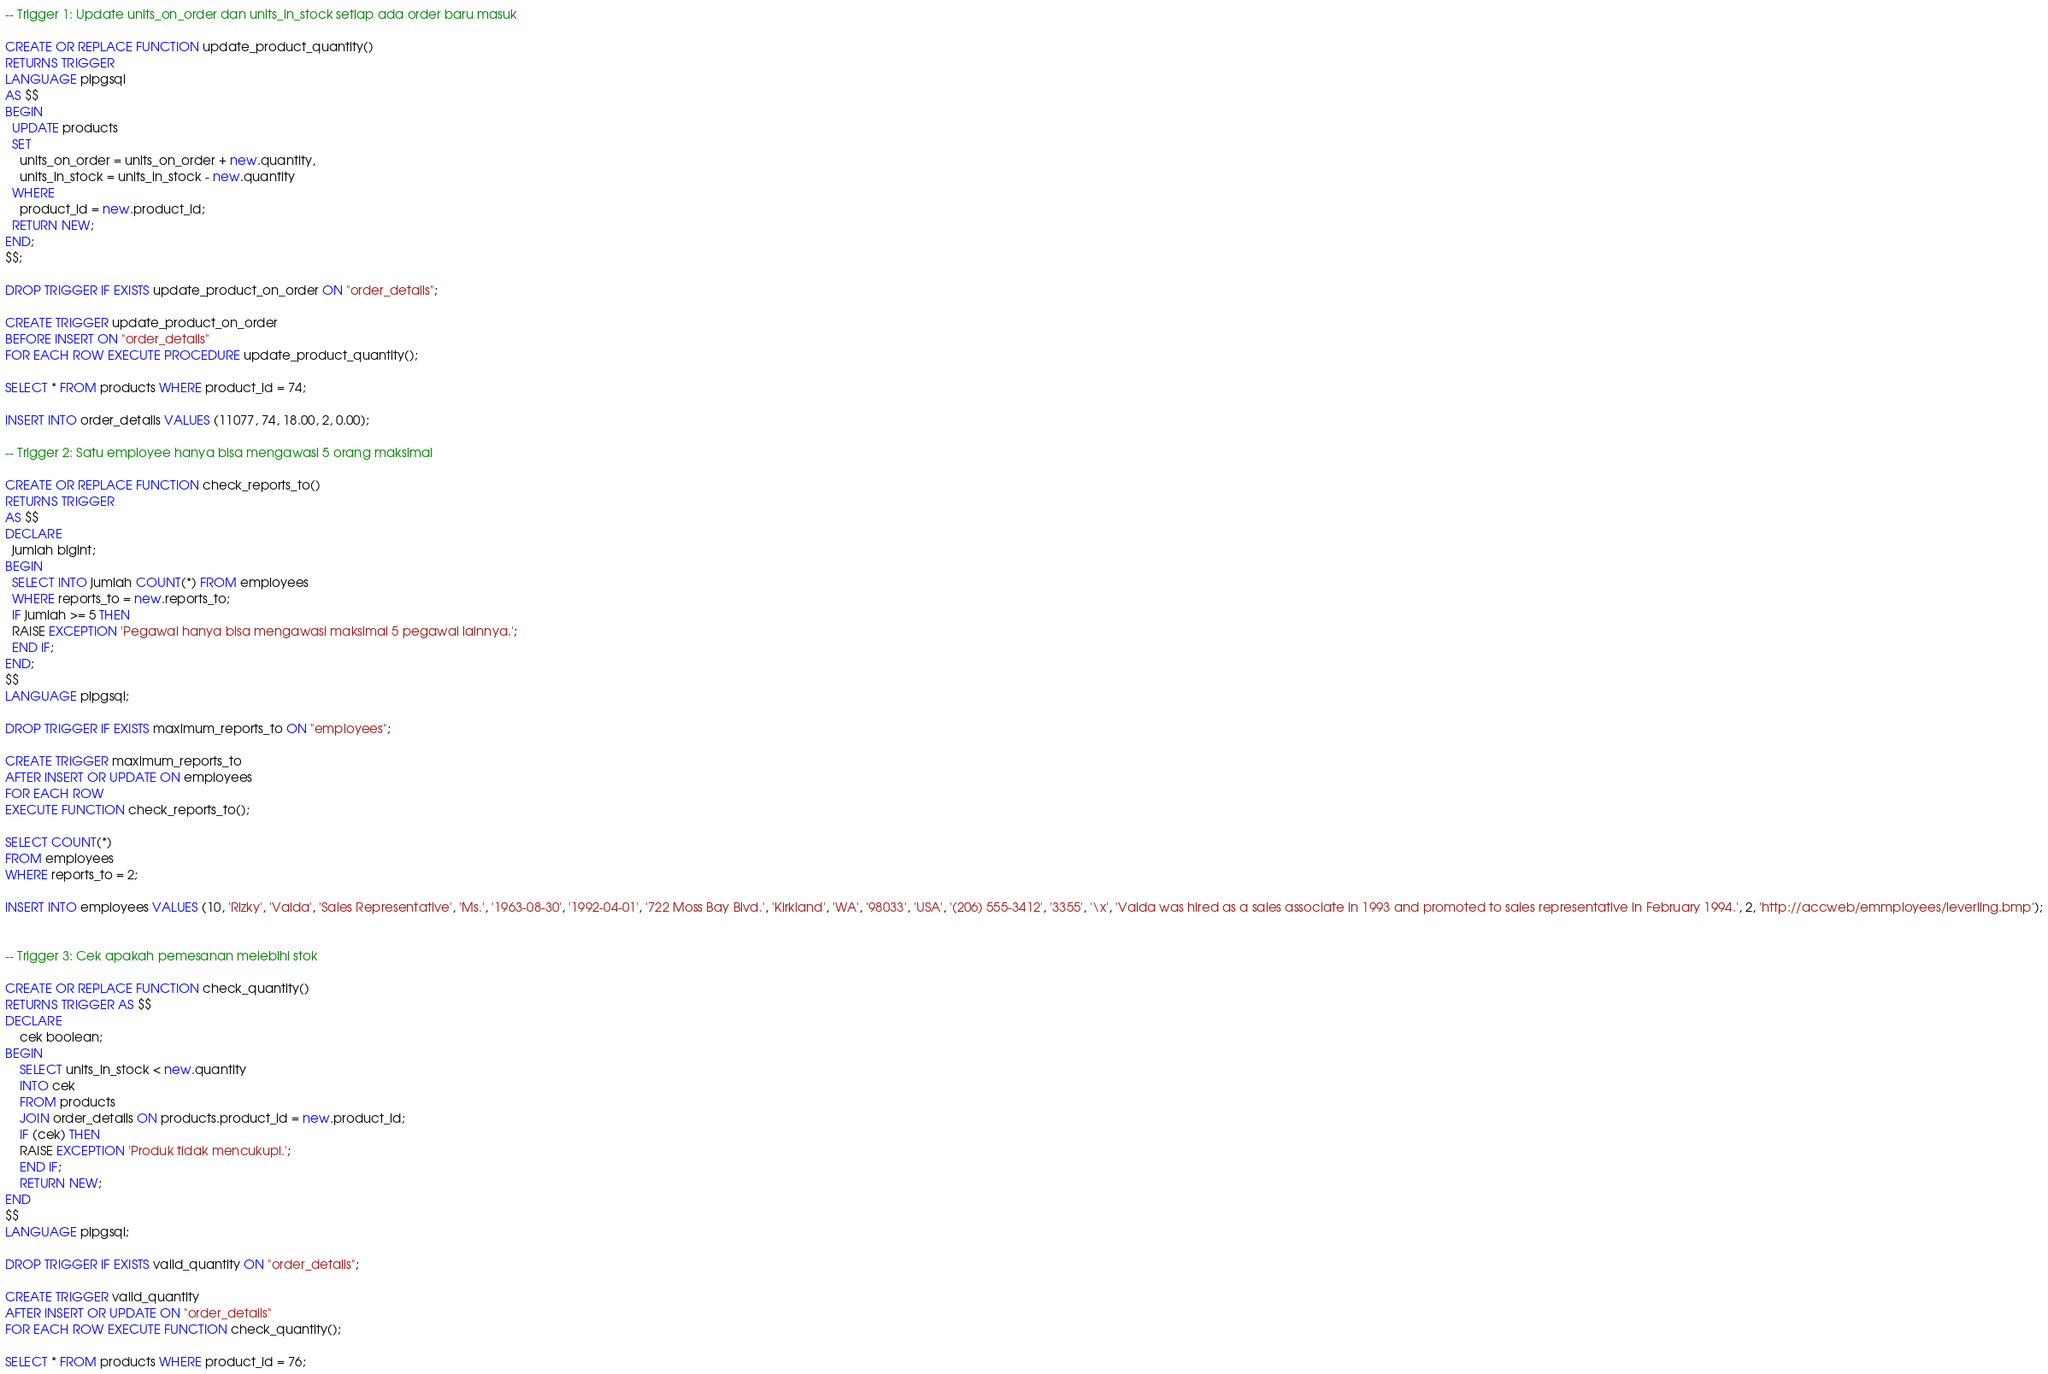<code> <loc_0><loc_0><loc_500><loc_500><_SQL_>-- Trigger 1: Update units_on_order dan units_in_stock setiap ada order baru masuk

CREATE OR REPLACE FUNCTION update_product_quantity()
RETURNS TRIGGER
LANGUAGE plpgsql
AS $$
BEGIN
  UPDATE products
  SET
    units_on_order = units_on_order + new.quantity,
    units_in_stock = units_in_stock - new.quantity
  WHERE
    product_id = new.product_id;
  RETURN NEW;
END;
$$;

DROP TRIGGER IF EXISTS update_product_on_order ON "order_details";

CREATE TRIGGER update_product_on_order 
BEFORE INSERT ON "order_details"
FOR EACH ROW EXECUTE PROCEDURE update_product_quantity();

SELECT * FROM products WHERE product_id = 74;

INSERT INTO order_details VALUES (11077, 74, 18.00, 2, 0.00);

-- Trigger 2: Satu employee hanya bisa mengawasi 5 orang maksimal

CREATE OR REPLACE FUNCTION check_reports_to()
RETURNS TRIGGER
AS $$
DECLARE
  jumlah bigint;
BEGIN
  SELECT INTO jumlah COUNT(*) FROM employees 
  WHERE reports_to = new.reports_to;
  IF jumlah >= 5 THEN
  RAISE EXCEPTION 'Pegawai hanya bisa mengawasi maksimal 5 pegawai lainnya.';  
  END IF;
END;
$$
LANGUAGE plpgsql;

DROP TRIGGER IF EXISTS maximum_reports_to ON "employees";

CREATE TRIGGER maximum_reports_to
AFTER INSERT OR UPDATE ON employees
FOR EACH ROW
EXECUTE FUNCTION check_reports_to();

SELECT COUNT(*)
FROM employees 
WHERE reports_to = 2;

INSERT INTO employees VALUES (10, 'Rizky', 'Valda', 'Sales Representative', 'Ms.', '1963-08-30', '1992-04-01', '722 Moss Bay Blvd.', 'Kirkland', 'WA', '98033', 'USA', '(206) 555-3412', '3355', '\x', 'Valda was hired as a sales associate in 1993 and promoted to sales representative in February 1994.', 2, 'http://accweb/emmployees/leverling.bmp');


-- Trigger 3: Cek apakah pemesanan melebihi stok

CREATE OR REPLACE FUNCTION check_quantity()
RETURNS TRIGGER AS $$
DECLARE
	cek boolean;
BEGIN
	SELECT units_in_stock < new.quantity 
	INTO cek
	FROM products
    JOIN order_details ON products.product_id = new.product_id;
	IF (cek) THEN
    RAISE EXCEPTION 'Produk tidak mencukupi.';
	END IF;
	RETURN NEW;
END
$$
LANGUAGE plpgsql;

DROP TRIGGER IF EXISTS valid_quantity ON "order_details";

CREATE TRIGGER valid_quantity
AFTER INSERT OR UPDATE ON "order_details"
FOR EACH ROW EXECUTE FUNCTION check_quantity();

SELECT * FROM products WHERE product_id = 76;</code> 